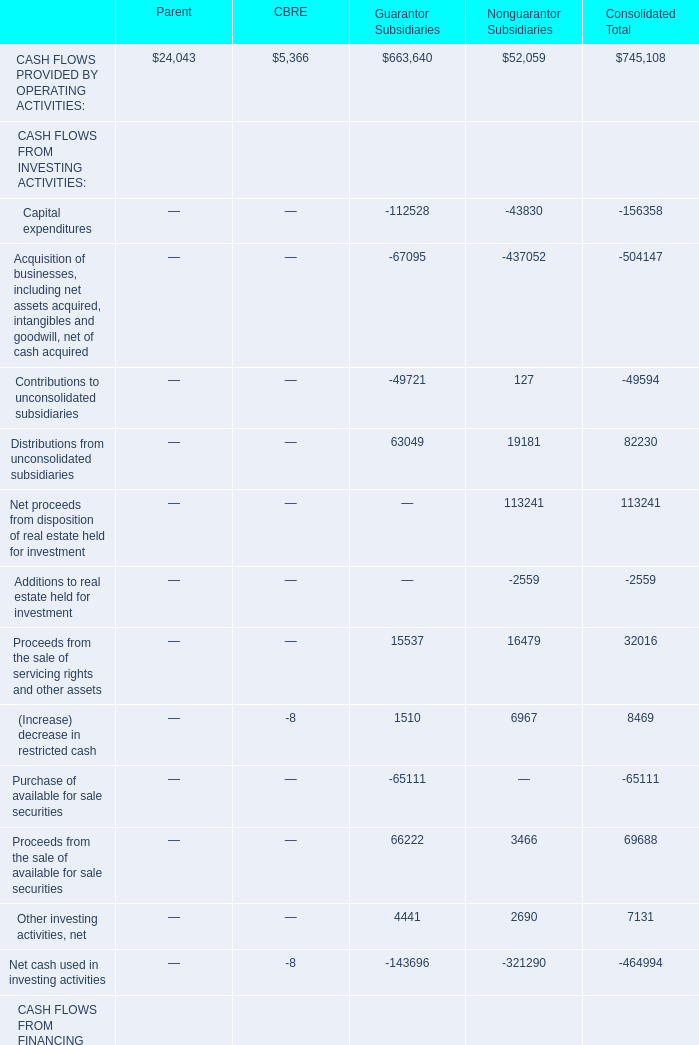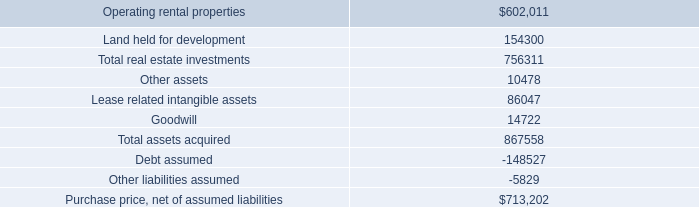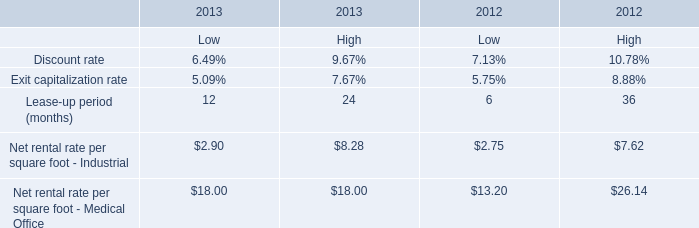what was the ratio of the debts to the assets in the purchase transaction 
Computations: ((5829 + 148527) / 867558)
Answer: 0.17792. 